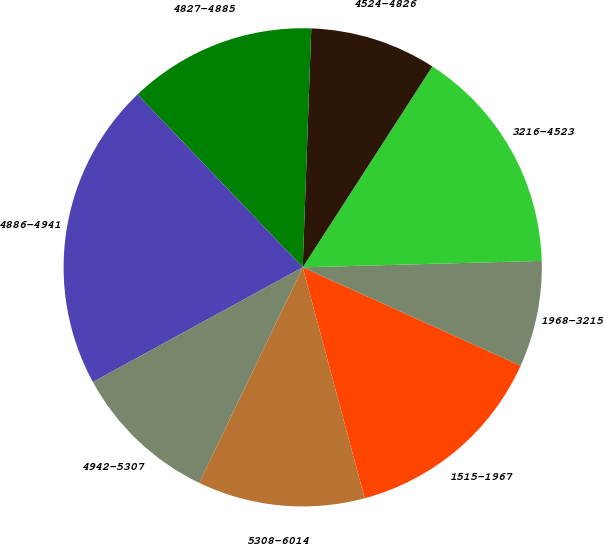Convert chart to OTSL. <chart><loc_0><loc_0><loc_500><loc_500><pie_chart><fcel>1515-1967<fcel>1968-3215<fcel>3216-4523<fcel>4524-4826<fcel>4827-4885<fcel>4886-4941<fcel>4942-5307<fcel>5308-6014<nl><fcel>14.08%<fcel>7.18%<fcel>15.45%<fcel>8.55%<fcel>12.71%<fcel>20.82%<fcel>9.92%<fcel>11.29%<nl></chart> 